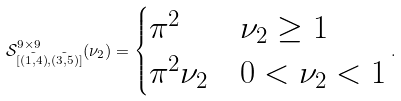Convert formula to latex. <formula><loc_0><loc_0><loc_500><loc_500>\mathcal { S } _ { [ \tilde { ( 1 , 4 ) } , \tilde { ( 3 , 5 ) } ] } ^ { 9 \times 9 } ( \nu _ { 2 } ) = \begin{cases} \pi ^ { 2 } & \nu _ { 2 } \geq 1 \\ \pi ^ { 2 } \nu _ { 2 } & 0 < \nu _ { 2 } < 1 \end{cases} .</formula> 